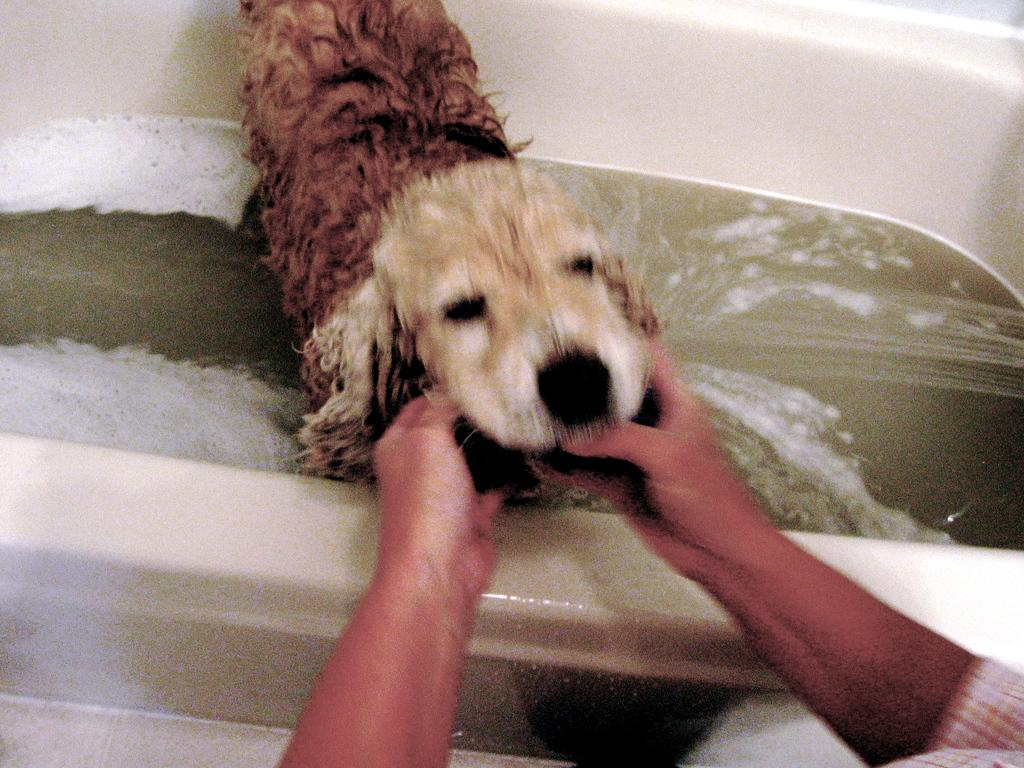What is happening in the image? There is a person giving a bath to a dog in the image. Where is the dog being bathed? The dog is in a bathtub. What can be seen in the bathtub along with the dog? There is water present in the image. What type of shoes is the person wearing while giving a bath to the dog in the image? The provided facts do not mention the type of shoes the person is wearing, so it cannot be determined from the image. 